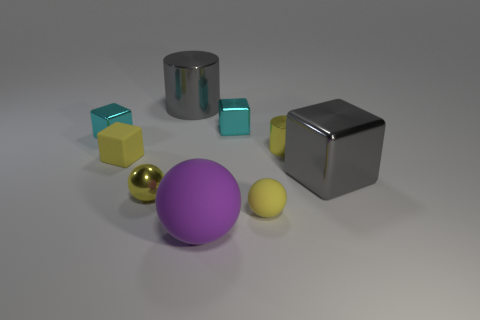How many metallic things are to the left of the object right of the yellow metallic cylinder to the right of the yellow rubber sphere?
Ensure brevity in your answer.  5. Is the number of gray cylinders left of the gray metal cylinder the same as the number of large purple matte objects that are right of the big purple ball?
Keep it short and to the point. Yes. How many yellow rubber things are the same shape as the big purple thing?
Offer a terse response. 1. Is there a brown cylinder that has the same material as the gray cylinder?
Your answer should be compact. No. The metal thing that is the same color as the large cube is what shape?
Your answer should be compact. Cylinder. How many big gray shiny things are there?
Make the answer very short. 2. What number of balls are big gray shiny things or big objects?
Make the answer very short. 1. What is the color of the matte block that is the same size as the yellow shiny sphere?
Keep it short and to the point. Yellow. What number of rubber things are in front of the small metallic sphere and behind the large rubber ball?
Ensure brevity in your answer.  1. What material is the purple sphere?
Your answer should be compact. Rubber. 